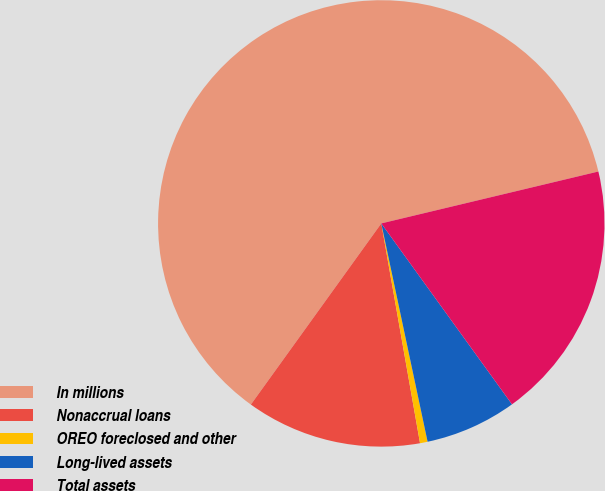Convert chart. <chart><loc_0><loc_0><loc_500><loc_500><pie_chart><fcel>In millions<fcel>Nonaccrual loans<fcel>OREO foreclosed and other<fcel>Long-lived assets<fcel>Total assets<nl><fcel>61.34%<fcel>12.71%<fcel>0.55%<fcel>6.63%<fcel>18.78%<nl></chart> 